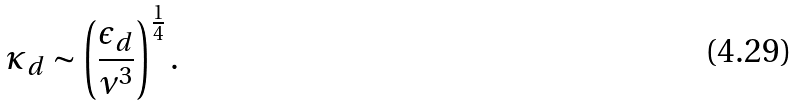Convert formula to latex. <formula><loc_0><loc_0><loc_500><loc_500>\kappa _ { d } \sim \left ( \frac { \epsilon _ { d } } { \nu ^ { 3 } } \right ) ^ { \frac { 1 } { 4 } } .</formula> 